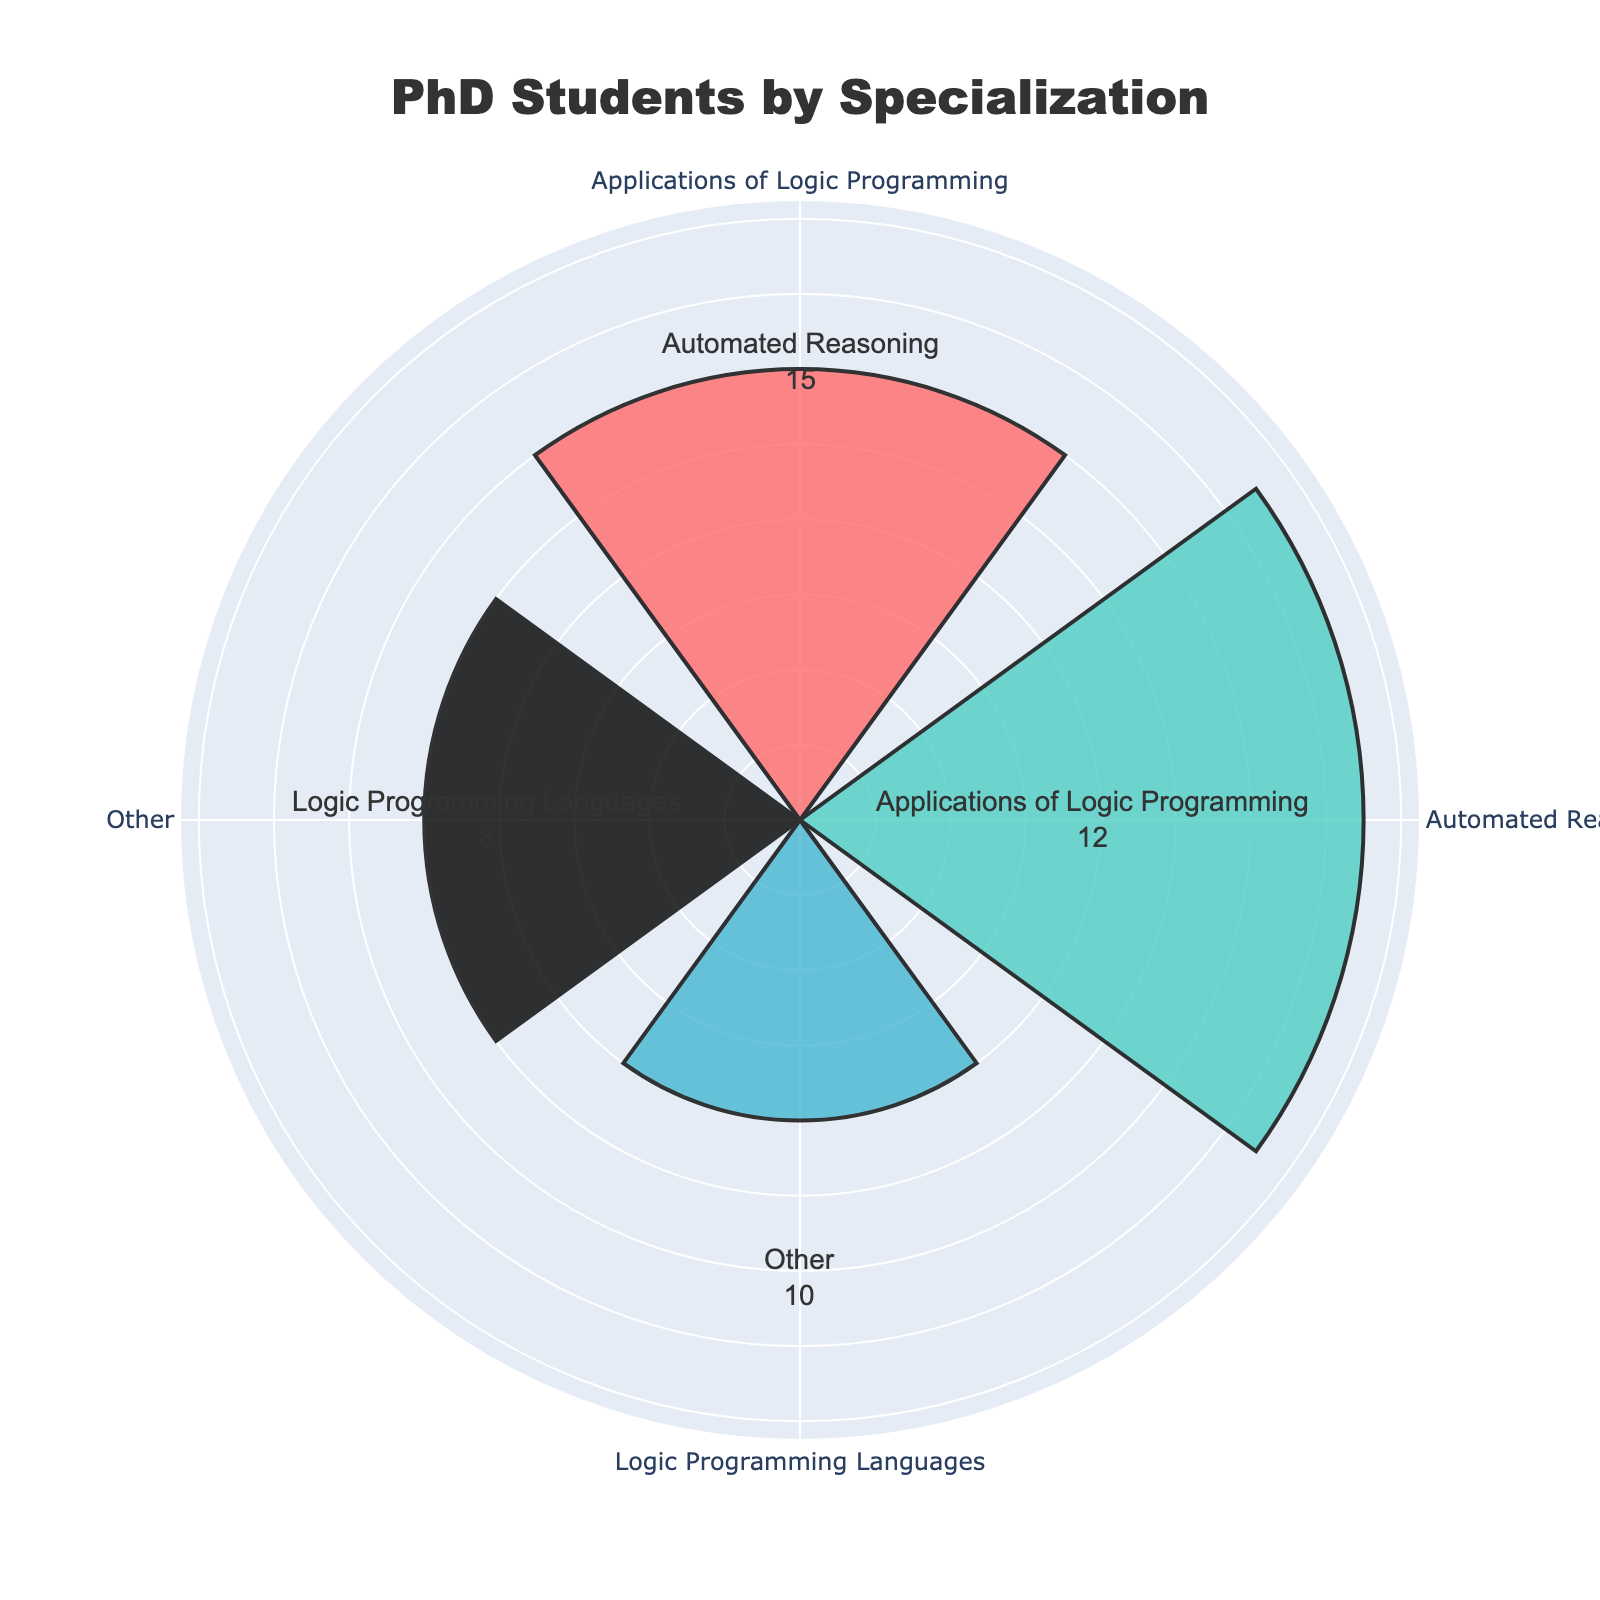What is the title of the chart? The title of the chart is prominently displayed at the top of the figure. It gives an overview of what the chart represents.
Answer: "PhD Students by Specialization" How many specializations are shown in the chart? The radial axis of the rose chart indicates three distinct specializations after combining the two smallest categories.
Answer: 3 Which specialization has the highest number of PhD students? By comparing the length of the radial bars, we identify that the specialization with the longest bar represents the highest number of PhD students.
Answer: Automated Reasoning What are the three specializations displayed on the chart? By looking at the theta labels around the chart, we can identify the three specializations.
Answer: "Automated Reasoning", "Applications of Logic Programming", "Other" How many PhD students are there in total across all specializations? Sum the number of PhD students in each specialization: 15 (Automated Reasoning) + 12 (Applications of Logic Programming) + 18 (Other) = 45
Answer: 45 Which specialization has the shortest bar, and how many students does it represent? By identifying the shortest bar in the chart and looking at its value, we find the specialization and its corresponding number of students.
Answer: Other, 18 How does the number of PhD students in “Applications of Logic Programming” compare to those in “Automated Reasoning”? The radial bar for "Applications of Logic Programming" is shorter than that of "Automated Reasoning", indicating fewer PhD students. Specifically, it has 12 compared to 15 in "Automated Reasoning".
Answer: "Applications of Logic Programming" has 3 fewer students than "Automated Reasoning" What is the average number of PhD students per specialization? Calculate the average by summing the students in each specialization and dividing by the number of specializations: (15 + 12 + 18) / 3 = 45 / 3 = 15
Answer: 15 What proportion of the total PhD students does the “Automated Reasoning” specialization represent? Divide the number of students in "Automated Reasoning" by the total number of students and multiply by 100: (15 / 45) * 100 = 33.3%
Answer: 33.3% How many PhD students fall under the "Other" category? This is found by combining the students from "Constraint Logic Programming" (10) and "Logic Programming Languages" (8): 10 + 8 = 18
Answer: 18 